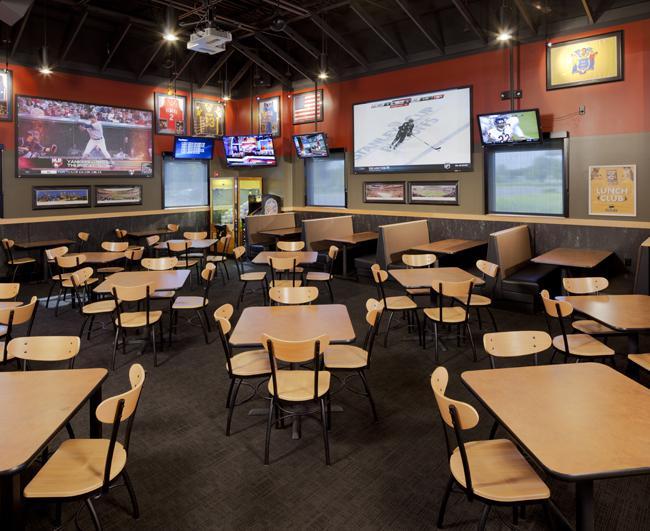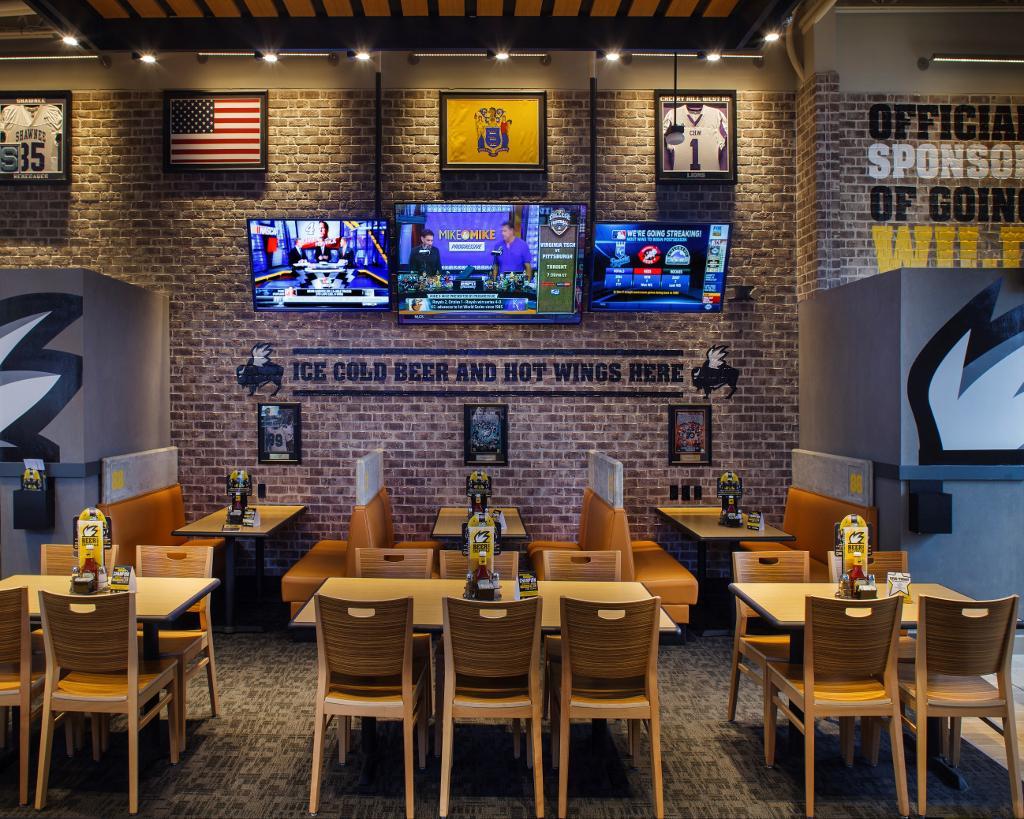The first image is the image on the left, the second image is the image on the right. Considering the images on both sides, is "A yellow wall can be seen in the background of the left image." valid? Answer yes or no. No. The first image is the image on the left, the second image is the image on the right. Considering the images on both sides, is "One bar area has a yellow ceiling and stools with backs at the bar." valid? Answer yes or no. No. 